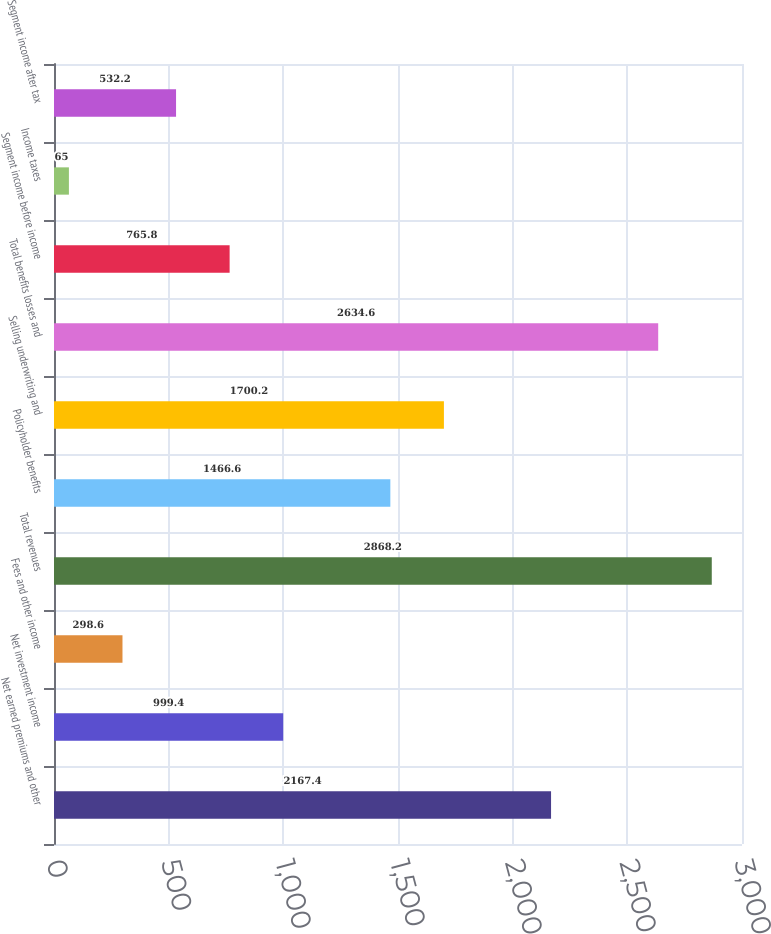Convert chart to OTSL. <chart><loc_0><loc_0><loc_500><loc_500><bar_chart><fcel>Net earned premiums and other<fcel>Net investment income<fcel>Fees and other income<fcel>Total revenues<fcel>Policyholder benefits<fcel>Selling underwriting and<fcel>Total benefits losses and<fcel>Segment income before income<fcel>Income taxes<fcel>Segment income after tax<nl><fcel>2167.4<fcel>999.4<fcel>298.6<fcel>2868.2<fcel>1466.6<fcel>1700.2<fcel>2634.6<fcel>765.8<fcel>65<fcel>532.2<nl></chart> 